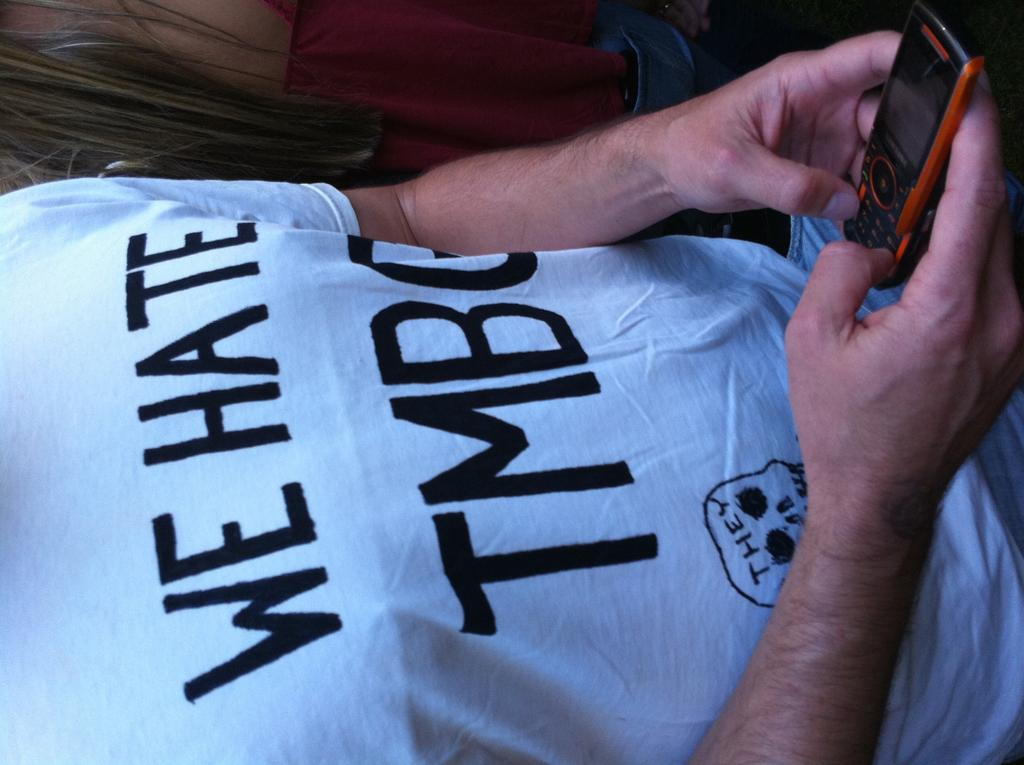<image>
Write a terse but informative summary of the picture. The man's tee shirt expresses that he hates a group or person with a name that starts with TMB. 